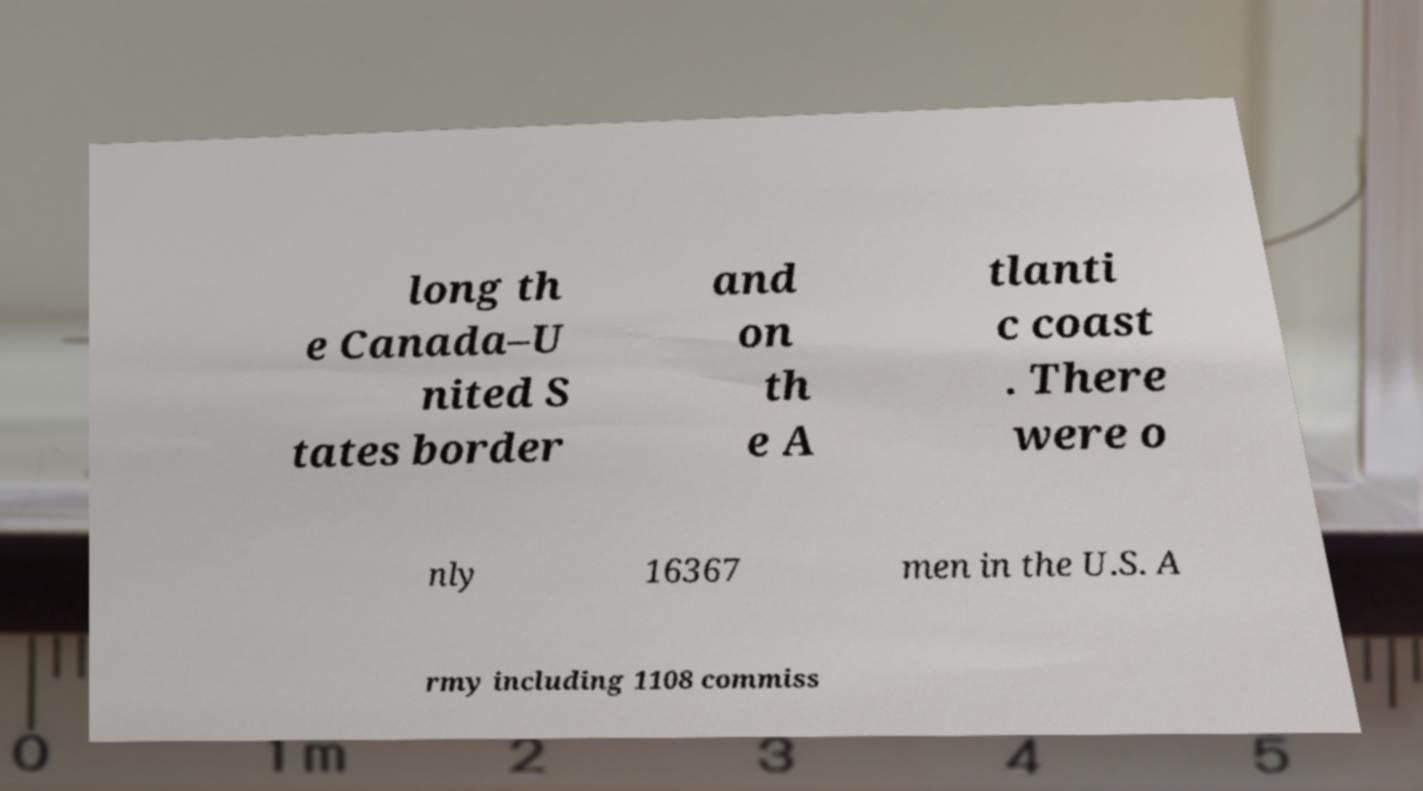There's text embedded in this image that I need extracted. Can you transcribe it verbatim? long th e Canada–U nited S tates border and on th e A tlanti c coast . There were o nly 16367 men in the U.S. A rmy including 1108 commiss 